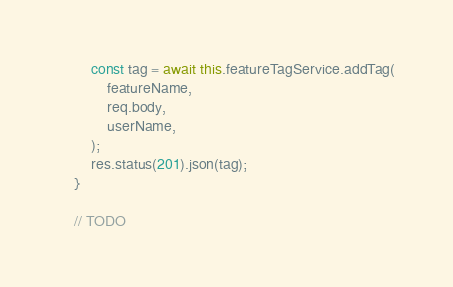<code> <loc_0><loc_0><loc_500><loc_500><_TypeScript_>        const tag = await this.featureTagService.addTag(
            featureName,
            req.body,
            userName,
        );
        res.status(201).json(tag);
    }

    // TODO</code> 